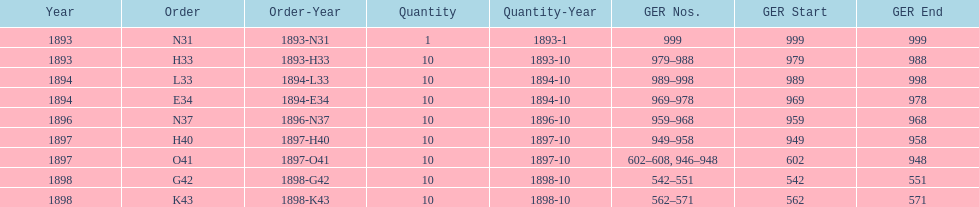Was the quantity higher in 1894 or 1893? 1894. 